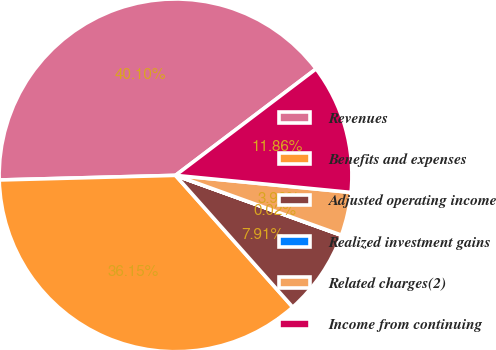Convert chart to OTSL. <chart><loc_0><loc_0><loc_500><loc_500><pie_chart><fcel>Revenues<fcel>Benefits and expenses<fcel>Adjusted operating income<fcel>Realized investment gains<fcel>Related charges(2)<fcel>Income from continuing<nl><fcel>40.1%<fcel>36.15%<fcel>7.91%<fcel>0.02%<fcel>3.96%<fcel>11.86%<nl></chart> 